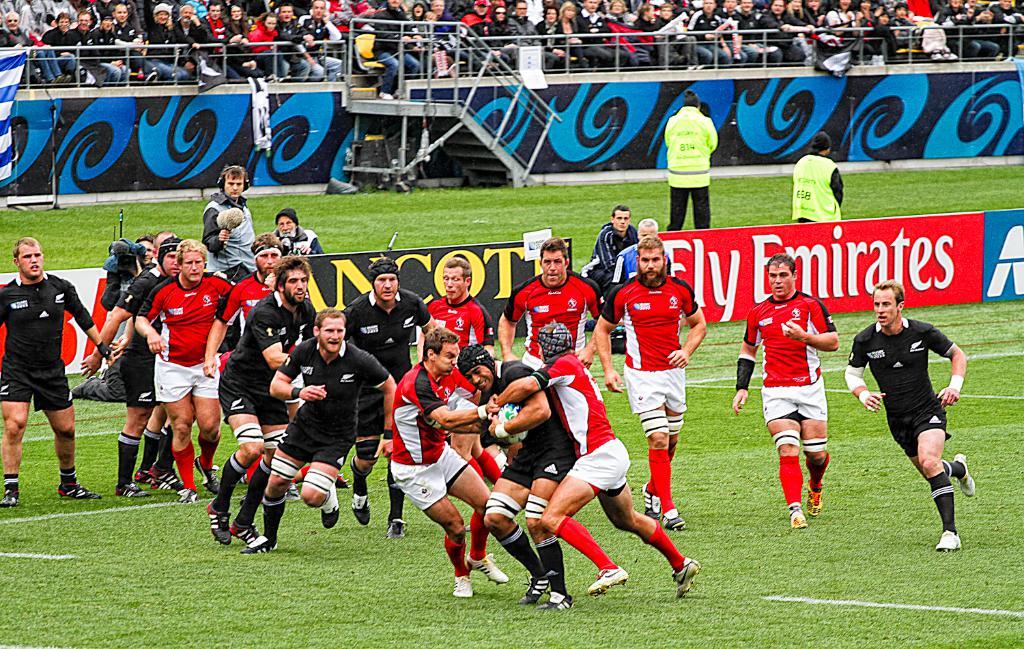What is the sponsor with the red background?
Your answer should be compact. Fly emirates. 